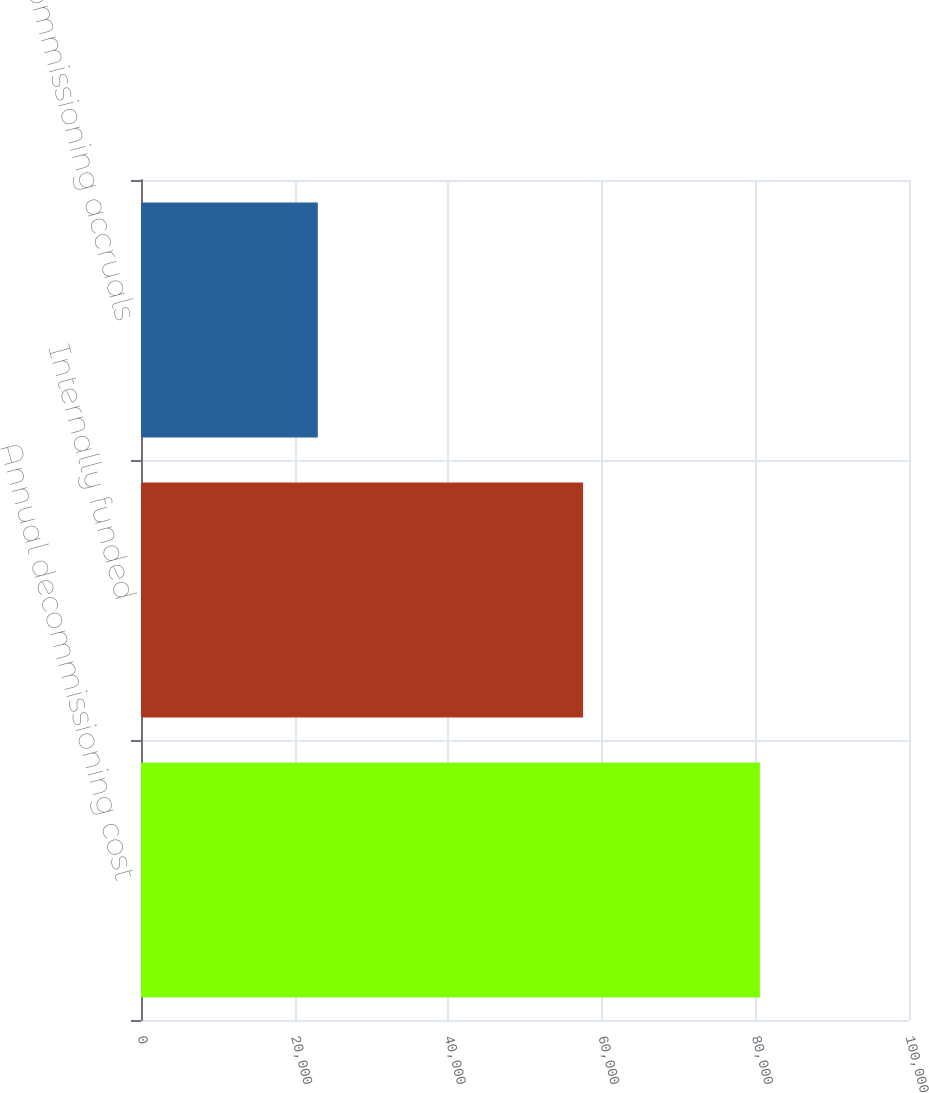<chart> <loc_0><loc_0><loc_500><loc_500><bar_chart><fcel>Annual decommissioning cost<fcel>Internally funded<fcel>Net decommissioning accruals<nl><fcel>80582<fcel>57561<fcel>23021<nl></chart> 